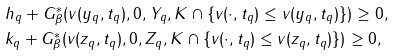<formula> <loc_0><loc_0><loc_500><loc_500>& h _ { q } + G _ { \beta } ^ { \ast } ( v ( y _ { q } , t _ { q } ) , 0 , Y _ { q } , K \cap \{ v ( \cdot , t _ { q } ) \leq v ( y _ { q } , t _ { q } ) \} ) \geq 0 , \\ & k _ { q } + G _ { \beta } ^ { \ast } ( v ( z _ { q } , t _ { q } ) , 0 , Z _ { q } , K \cap \{ v ( \cdot , t _ { q } ) \leq v ( z _ { q } , t _ { q } ) \} ) \geq 0 ,</formula> 